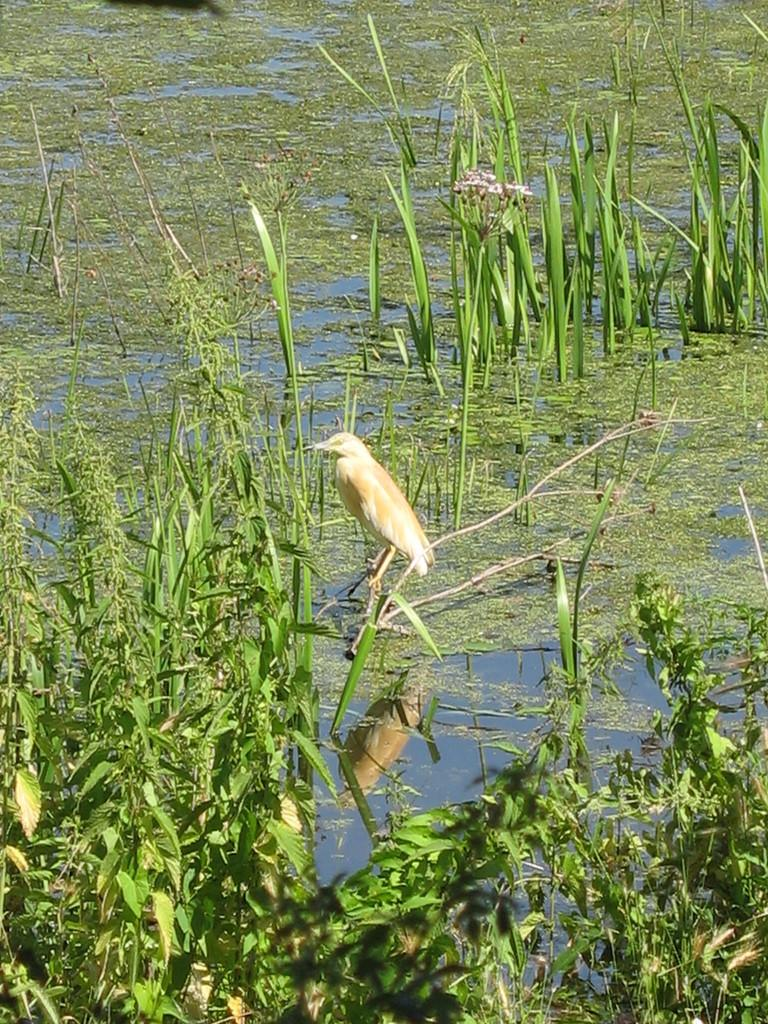What type of animal can be seen in the image? There is a bird in the image. Where is the bird located? The bird is standing on a plant. What is the condition of the ground in the image? The ground is covered with water. What type of vegetation is present on the ground? Plants are present on the ground. Reasoning: Let's think step by following the guidelines to produce the conversation. We start by identifying the main subject in the image, which is the bird. Then, we describe the bird's location and the condition of the ground. Finally, we mention the presence of plants on the ground. Each question is designed to elicit a specific detail about the image that is known from the provided facts. Absurd Question/Answer: What is the bird's brother doing in the image? There is no mention of a brother or any other bird in the image. 